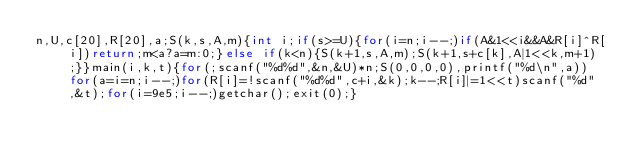<code> <loc_0><loc_0><loc_500><loc_500><_C_>n,U,c[20],R[20],a;S(k,s,A,m){int i;if(s>=U){for(i=n;i--;)if(A&1<<i&&A&R[i]^R[i])return;m<a?a=m:0;}else if(k<n){S(k+1,s,A,m);S(k+1,s+c[k],A|1<<k,m+1);}}main(i,k,t){for(;scanf("%d%d",&n,&U)*n;S(0,0,0,0),printf("%d\n",a))for(a=i=n;i--;)for(R[i]=!scanf("%d%d",c+i,&k);k--;R[i]|=1<<t)scanf("%d",&t);for(i=9e5;i--;)getchar();exit(0);}</code> 